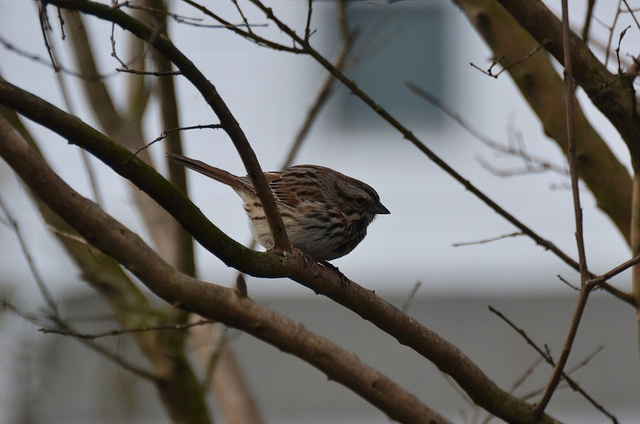Describe the objects in this image and their specific colors. I can see a bird in darkgray, black, and gray tones in this image. 